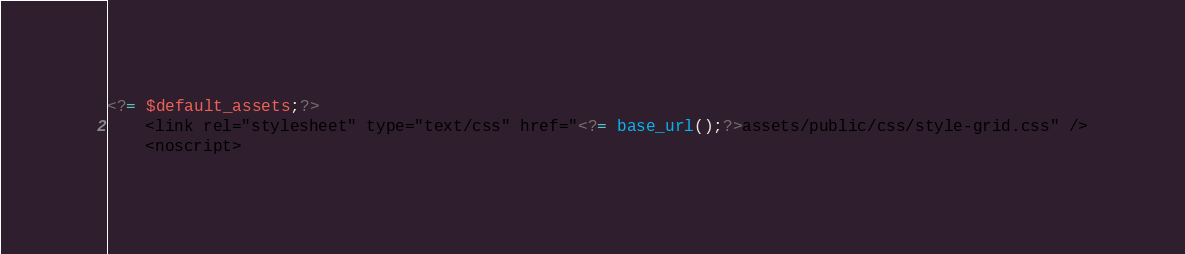Convert code to text. <code><loc_0><loc_0><loc_500><loc_500><_PHP_><?= $default_assets;?>
    <link rel="stylesheet" type="text/css" href="<?= base_url();?>assets/public/css/style-grid.css" />
    <noscript></code> 